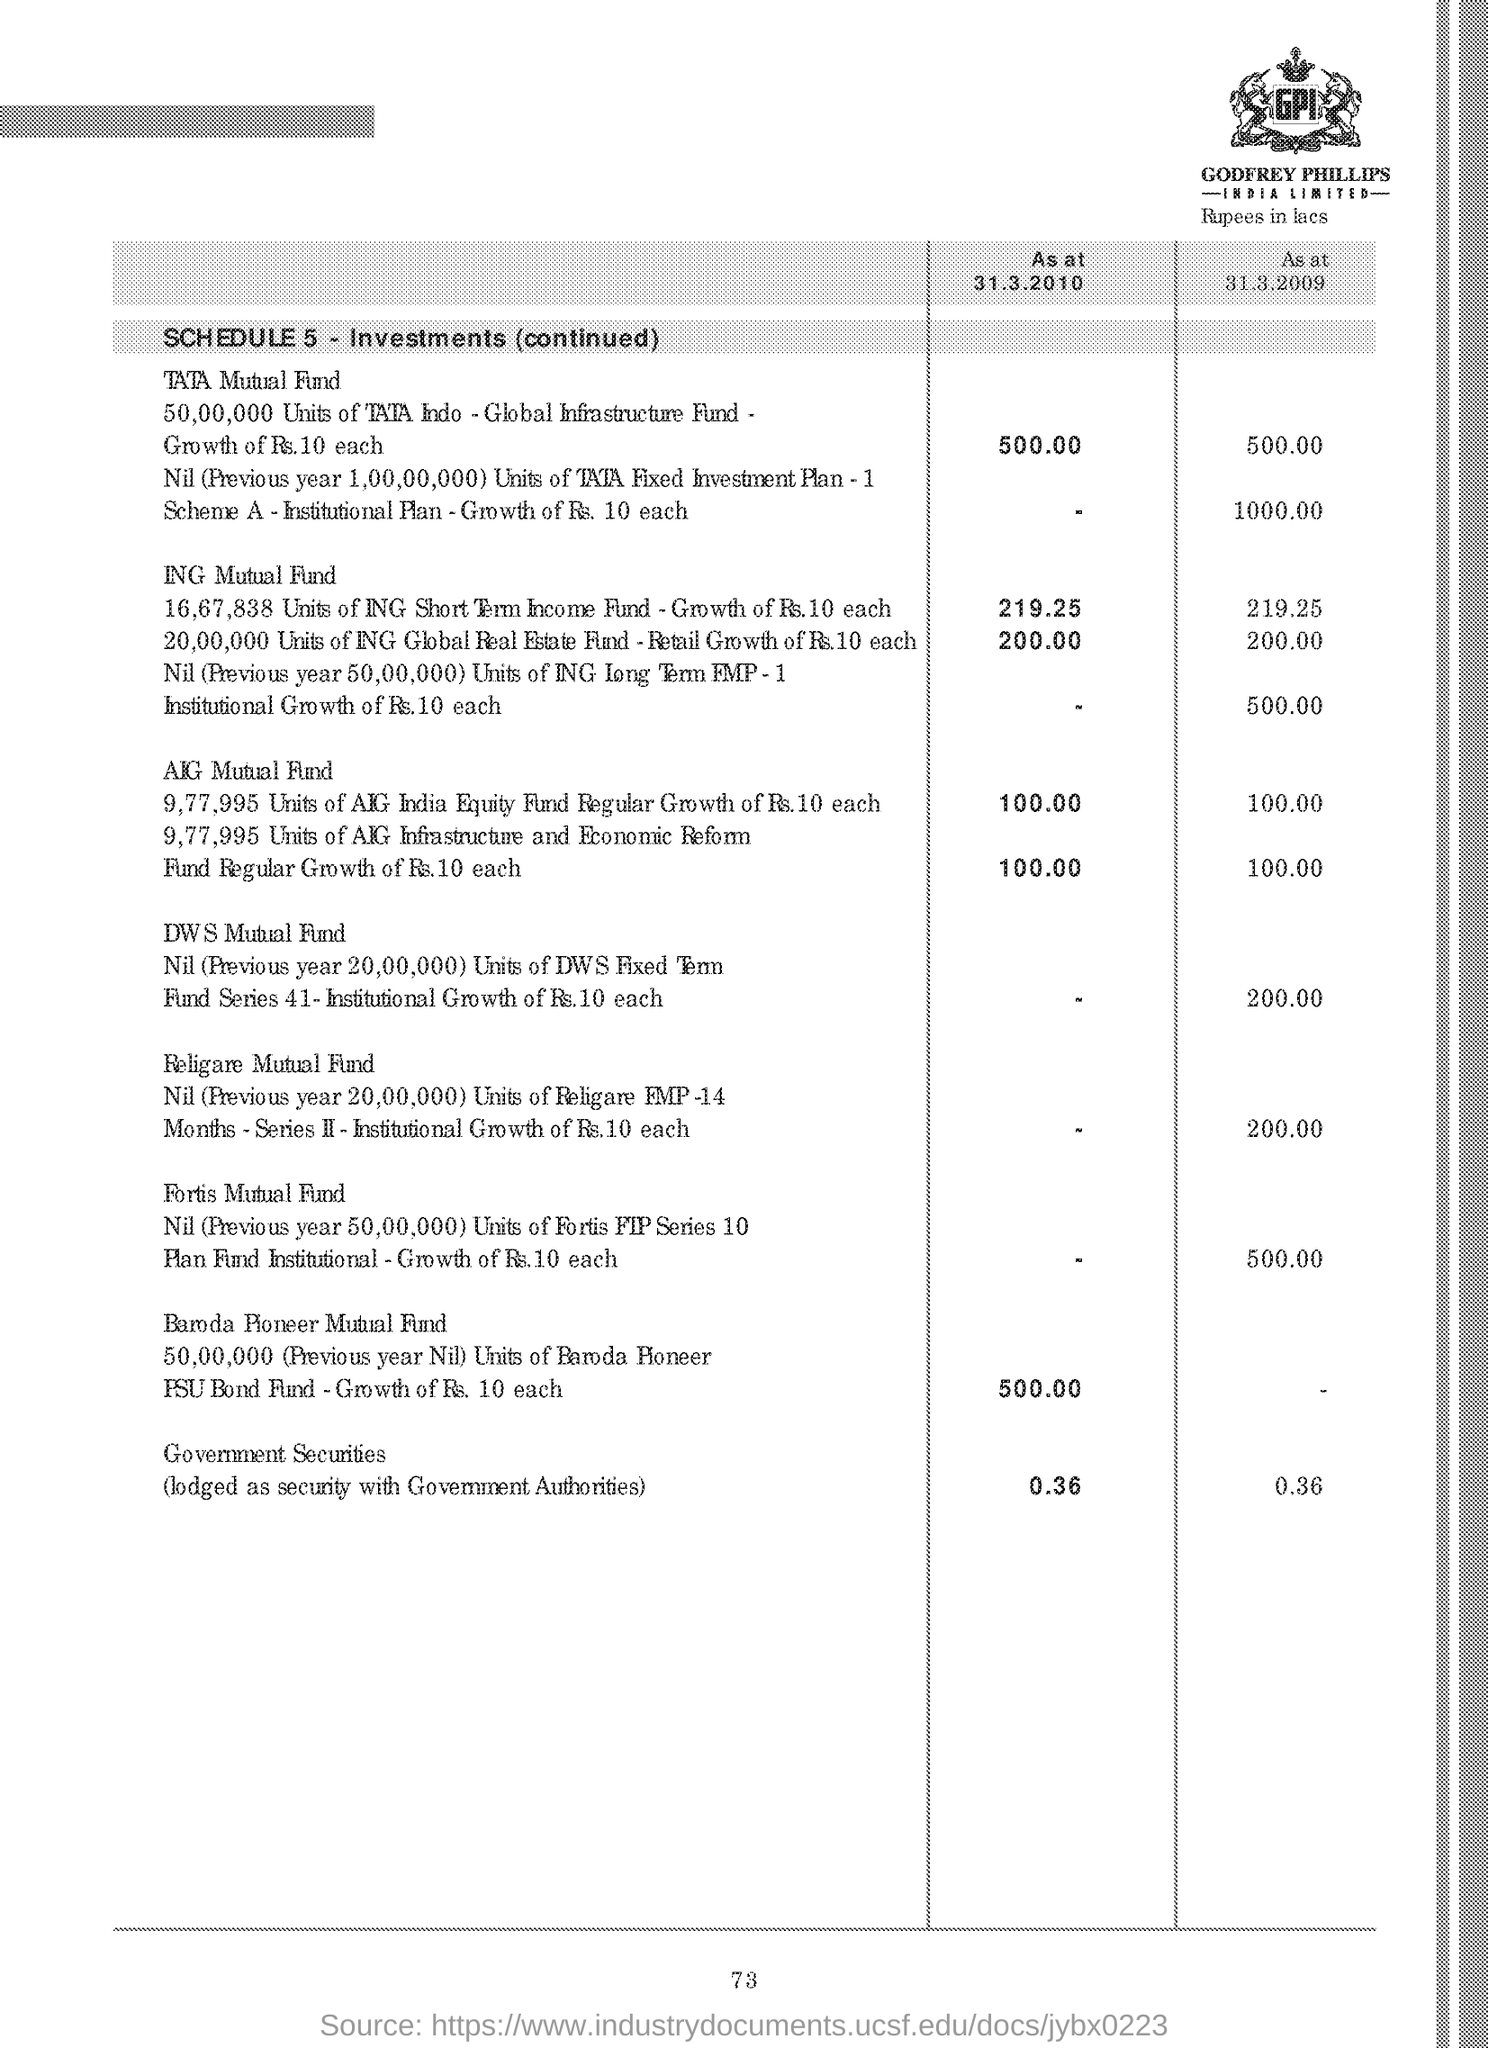What is the Page Number?
Offer a very short reply. 73. 